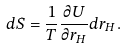<formula> <loc_0><loc_0><loc_500><loc_500>d S = \frac { 1 } { T } \frac { \partial U } { \partial r _ { H } } d r _ { H } .</formula> 